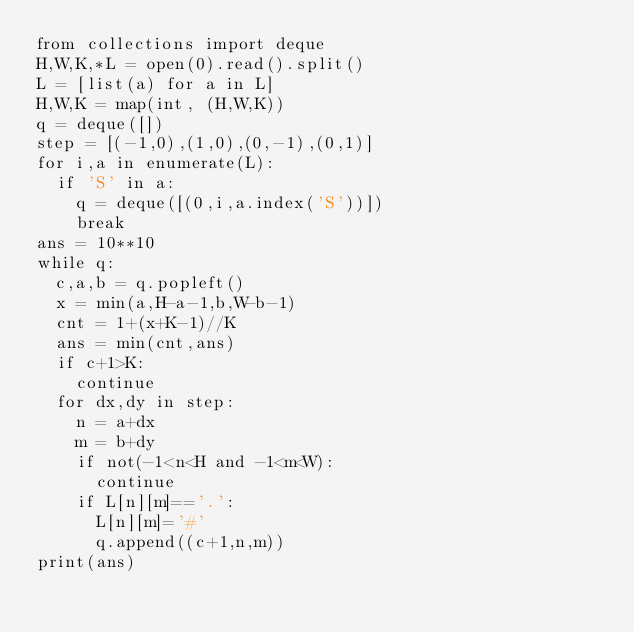Convert code to text. <code><loc_0><loc_0><loc_500><loc_500><_Python_>from collections import deque
H,W,K,*L = open(0).read().split()
L = [list(a) for a in L]
H,W,K = map(int, (H,W,K))
q = deque([])
step = [(-1,0),(1,0),(0,-1),(0,1)]
for i,a in enumerate(L):
  if 'S' in a:
    q = deque([(0,i,a.index('S'))])
    break
ans = 10**10
while q:
  c,a,b = q.popleft()
  x = min(a,H-a-1,b,W-b-1)
  cnt = 1+(x+K-1)//K
  ans = min(cnt,ans)
  if c+1>K:
    continue
  for dx,dy in step:
    n = a+dx
    m = b+dy
    if not(-1<n<H and -1<m<W):
      continue
    if L[n][m]=='.':
      L[n][m]='#'
      q.append((c+1,n,m))
print(ans)</code> 